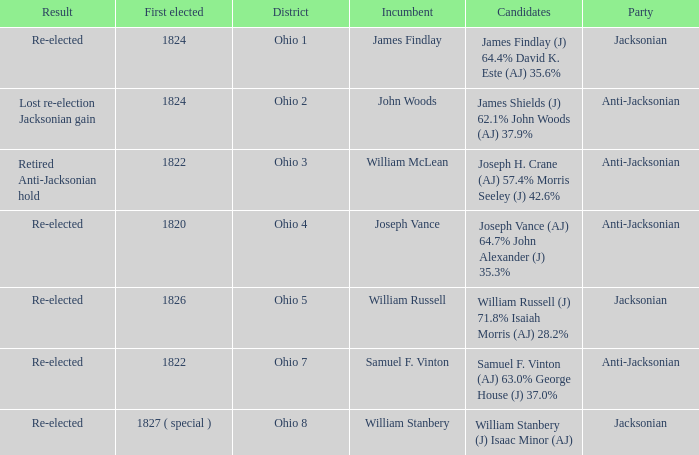What was the result for the candidate first elected in 1820? Re-elected. Could you parse the entire table as a dict? {'header': ['Result', 'First elected', 'District', 'Incumbent', 'Candidates', 'Party'], 'rows': [['Re-elected', '1824', 'Ohio 1', 'James Findlay', 'James Findlay (J) 64.4% David K. Este (AJ) 35.6%', 'Jacksonian'], ['Lost re-election Jacksonian gain', '1824', 'Ohio 2', 'John Woods', 'James Shields (J) 62.1% John Woods (AJ) 37.9%', 'Anti-Jacksonian'], ['Retired Anti-Jacksonian hold', '1822', 'Ohio 3', 'William McLean', 'Joseph H. Crane (AJ) 57.4% Morris Seeley (J) 42.6%', 'Anti-Jacksonian'], ['Re-elected', '1820', 'Ohio 4', 'Joseph Vance', 'Joseph Vance (AJ) 64.7% John Alexander (J) 35.3%', 'Anti-Jacksonian'], ['Re-elected', '1826', 'Ohio 5', 'William Russell', 'William Russell (J) 71.8% Isaiah Morris (AJ) 28.2%', 'Jacksonian'], ['Re-elected', '1822', 'Ohio 7', 'Samuel F. Vinton', 'Samuel F. Vinton (AJ) 63.0% George House (J) 37.0%', 'Anti-Jacksonian'], ['Re-elected', '1827 ( special )', 'Ohio 8', 'William Stanbery', 'William Stanbery (J) Isaac Minor (AJ)', 'Jacksonian']]} 